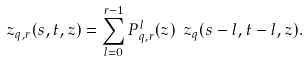Convert formula to latex. <formula><loc_0><loc_0><loc_500><loc_500>\ z _ { q , r } ( s , t , z ) = \sum ^ { r - 1 } _ { l = 0 } P ^ { l } _ { q , r } ( z ) \ z _ { q } ( s - l , t - l , z ) .</formula> 